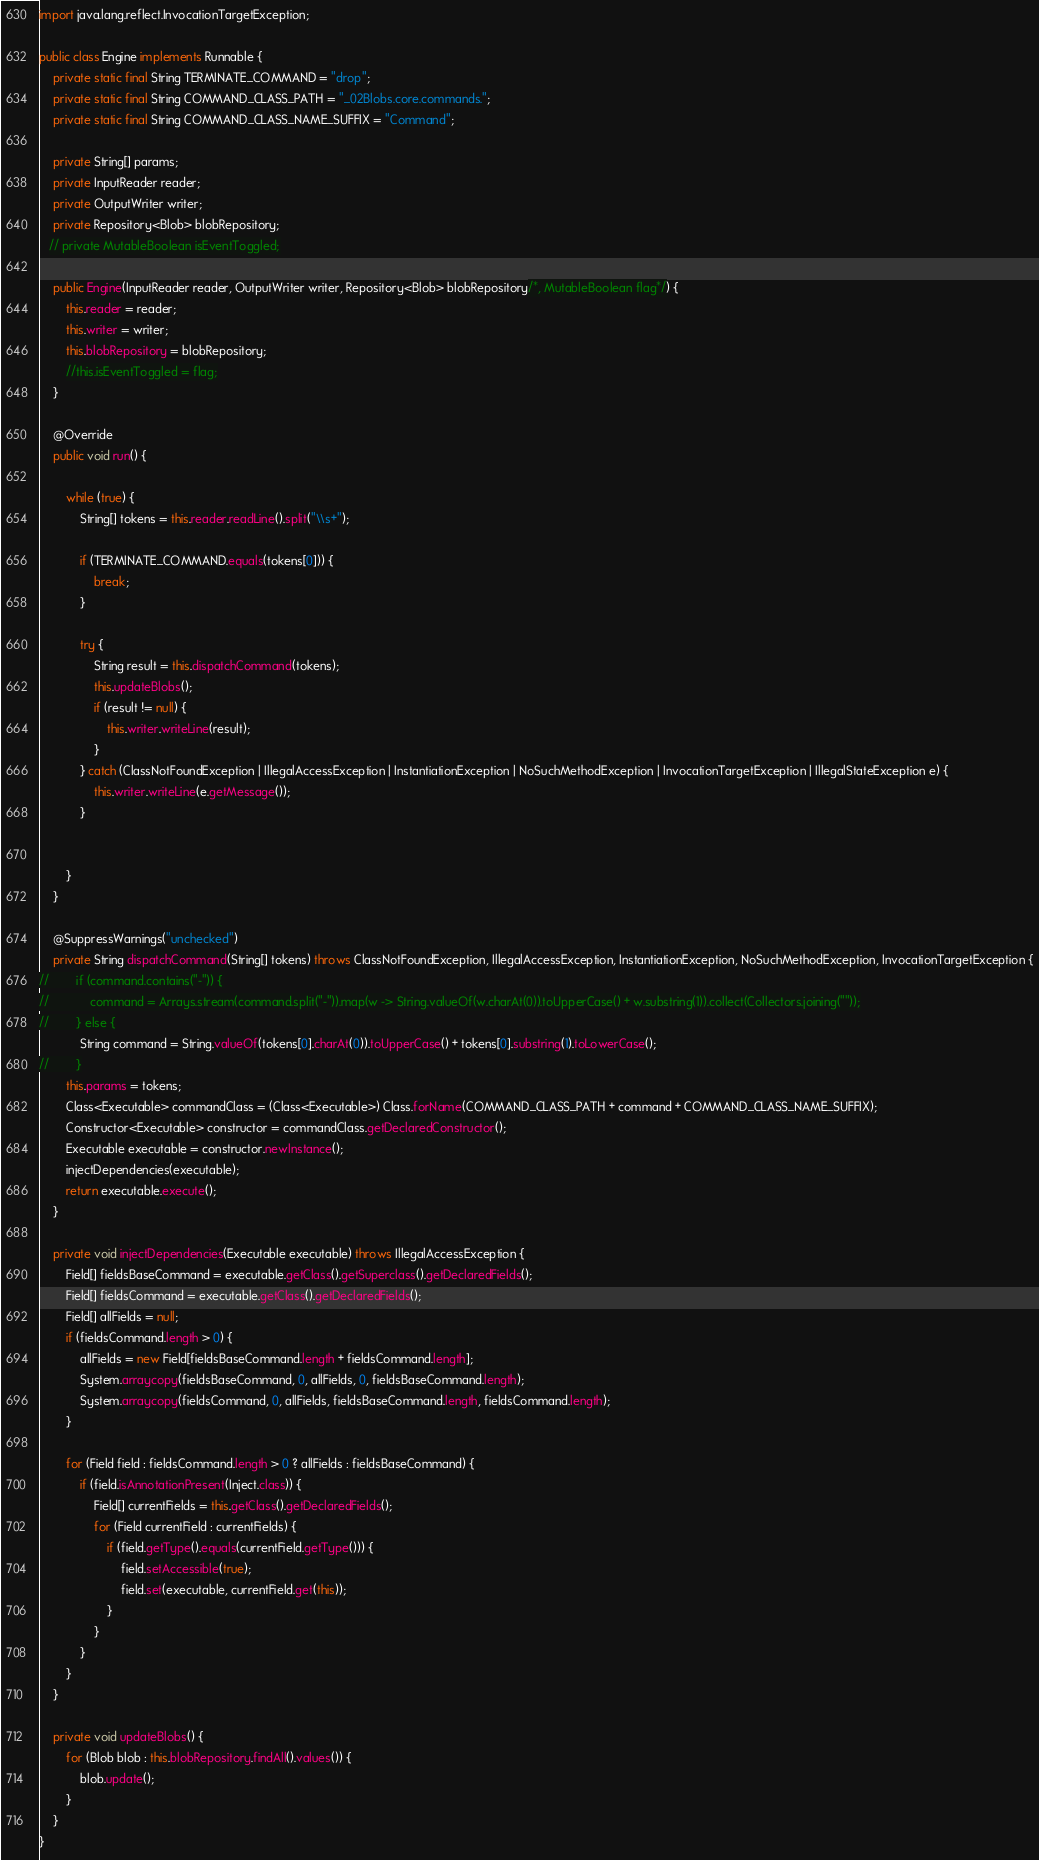Convert code to text. <code><loc_0><loc_0><loc_500><loc_500><_Java_>import java.lang.reflect.InvocationTargetException;

public class Engine implements Runnable {
    private static final String TERMINATE_COMMAND = "drop";
    private static final String COMMAND_CLASS_PATH = "_02Blobs.core.commands.";
    private static final String COMMAND_CLASS_NAME_SUFFIX = "Command";

    private String[] params;
    private InputReader reader;
    private OutputWriter writer;
    private Repository<Blob> blobRepository;
   // private MutableBoolean isEventToggled;

    public Engine(InputReader reader, OutputWriter writer, Repository<Blob> blobRepository/*, MutableBoolean flag*/) {
        this.reader = reader;
        this.writer = writer;
        this.blobRepository = blobRepository;
        //this.isEventToggled = flag;
    }

    @Override
    public void run() {

        while (true) {
            String[] tokens = this.reader.readLine().split("\\s+");

            if (TERMINATE_COMMAND.equals(tokens[0])) {
                break;
            }

            try {
                String result = this.dispatchCommand(tokens);
                this.updateBlobs();
                if (result != null) {
                    this.writer.writeLine(result);
                }
            } catch (ClassNotFoundException | IllegalAccessException | InstantiationException | NoSuchMethodException | InvocationTargetException | IllegalStateException e) {
                this.writer.writeLine(e.getMessage());
            }


        }
    }

    @SuppressWarnings("unchecked")
    private String dispatchCommand(String[] tokens) throws ClassNotFoundException, IllegalAccessException, InstantiationException, NoSuchMethodException, InvocationTargetException {
//        if (command.contains("-")) {
//            command = Arrays.stream(command.split("-")).map(w -> String.valueOf(w.charAt(0)).toUpperCase() + w.substring(1)).collect(Collectors.joining(""));
//        } else {
            String command = String.valueOf(tokens[0].charAt(0)).toUpperCase() + tokens[0].substring(1).toLowerCase();
//        }
        this.params = tokens;
        Class<Executable> commandClass = (Class<Executable>) Class.forName(COMMAND_CLASS_PATH + command + COMMAND_CLASS_NAME_SUFFIX);
        Constructor<Executable> constructor = commandClass.getDeclaredConstructor();
        Executable executable = constructor.newInstance();
        injectDependencies(executable);
        return executable.execute();
    }

    private void injectDependencies(Executable executable) throws IllegalAccessException {
        Field[] fieldsBaseCommand = executable.getClass().getSuperclass().getDeclaredFields();
        Field[] fieldsCommand = executable.getClass().getDeclaredFields();
        Field[] allFields = null;
        if (fieldsCommand.length > 0) {
            allFields = new Field[fieldsBaseCommand.length + fieldsCommand.length];
            System.arraycopy(fieldsBaseCommand, 0, allFields, 0, fieldsBaseCommand.length);
            System.arraycopy(fieldsCommand, 0, allFields, fieldsBaseCommand.length, fieldsCommand.length);
        }

        for (Field field : fieldsCommand.length > 0 ? allFields : fieldsBaseCommand) {
            if (field.isAnnotationPresent(Inject.class)) {
                Field[] currentFields = this.getClass().getDeclaredFields();
                for (Field currentField : currentFields) {
                    if (field.getType().equals(currentField.getType())) {
                        field.setAccessible(true);
                        field.set(executable, currentField.get(this));
                    }
                }
            }
        }
    }

    private void updateBlobs() {
        for (Blob blob : this.blobRepository.findAll().values()) {
            blob.update();
        }
    }
}
</code> 